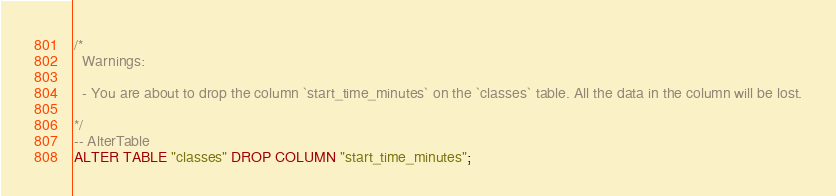<code> <loc_0><loc_0><loc_500><loc_500><_SQL_>/*
  Warnings:

  - You are about to drop the column `start_time_minutes` on the `classes` table. All the data in the column will be lost.

*/
-- AlterTable
ALTER TABLE "classes" DROP COLUMN "start_time_minutes";
</code> 